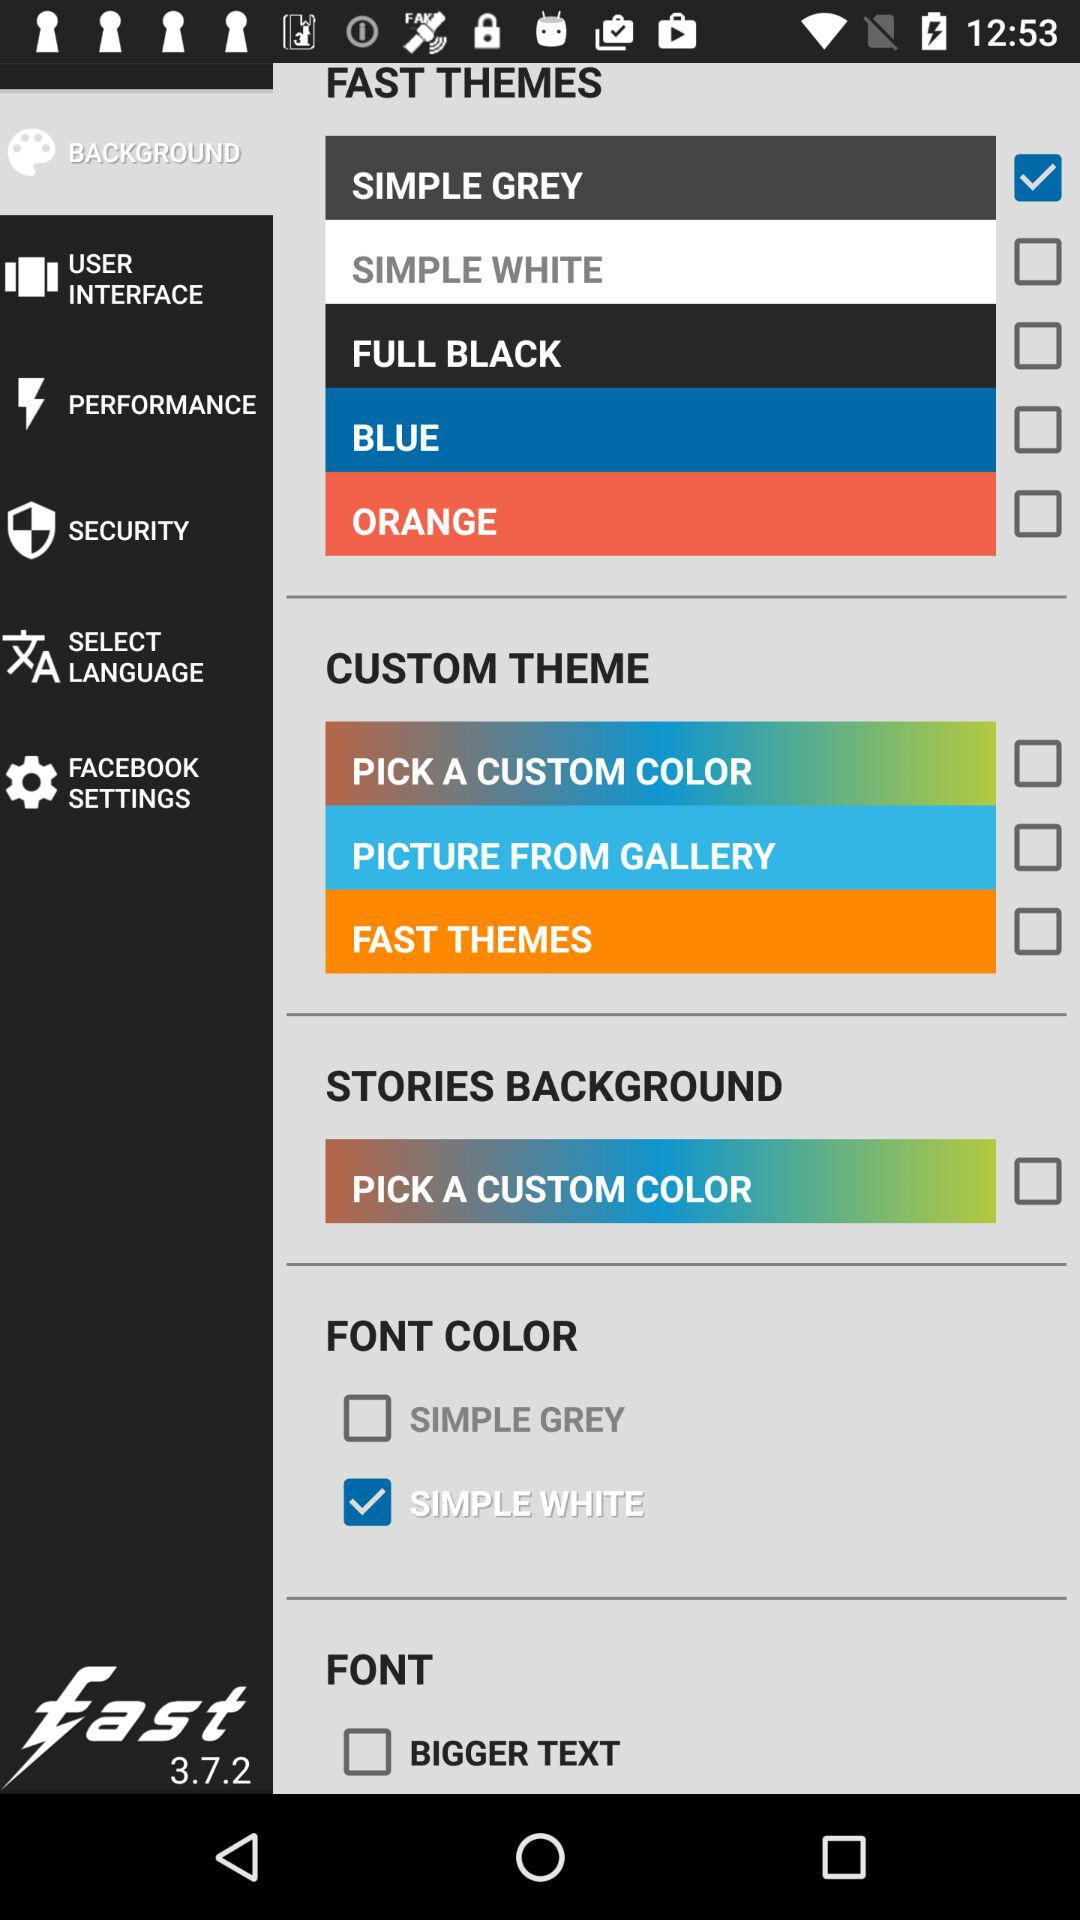Which is the selected font color? The selected font color is "SIMPLE WHITE". 